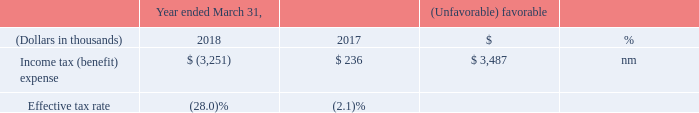Income Taxes
nm - not meaningful
For fiscal 2018, the effective tax rate was different than the statutory rate due primarily to the impact of the Tax Act reform. The Company recorded a benefit of approximately $3.3 million resulting from the effect of a reduction in the deferred rate and the ability to offset indefinite lived deferred tax liabilities with certain deferred tax assets, recognition of net operating losses as deferred tax assets, which were offset by increases in the valuation allowance, certain foreign and state tax effects including a benefit of $0.4 million related to a settlement with the California Franchise Tax Board and other U.S. permanent book to tax differences. At March 31, 2018, we had $198.7 million of a federal net operating loss carryforward that expires, if unused, in fiscal years 2031 to 2038.
For fiscal 2017, the effective tax rate was different than the statutory rate due primarily to the recognition of net operating losses as deferred tax assets, which were offset by increases in the valuation allowance, state taxes and other U.S. permanent book to tax differences.
Although the timing and outcome of tax settlements are uncertain, it is reasonably possible that during the next 12 months a reduction in unrecognized tax benefits may occur in the range of zero to $0.1 million of tax and zero to $0.2 million of interest based on the outcome of tax examinations and as a result of the expiration of various statutes of limitations. We are routinely audited; due to the ongoing nature of current examinations in multiple jurisdictions, other changes could occur in the amount of gross unrecognized tax benefits during the next 12 months which cannot be estimated at this time.
Because of our losses in prior periods, we have recorded a valuation allowance offsetting substantially all of our deferred tax assets. The ultimate realization of deferred tax assets generated prior to Tax Act reform depends on the generation of future taxable income during the periods in which those temporary differences are deductible. Because of our losses in prior periods, management believes that it is more-likely-than-not that we will not realize the benefits of these deductible differences.
What was the company recorded benefit resulting from the effect of reduction in rate? $3.3 million. What was the benefit related to a settlement with California Franchise Tax board? $0.4 million. What was the federal net operating loss carryforward at 31 March 2018? $198.7 million. What was the average income tax (benefit) expense for 2017 and 2018?
Answer scale should be: thousand. (-3,251 + 236) / 2
Answer: -1507.5. What was the average effective tax rate for 2017 and 2018?
Answer scale should be: percent. -(28.0 + 2.1) / 2
Answer: -15.05. What was the increase / (decrease) in the effective tax rate from 2017 to 2018?
Answer scale should be: percent. -28.0 - (-2.1)
Answer: -25.9. 